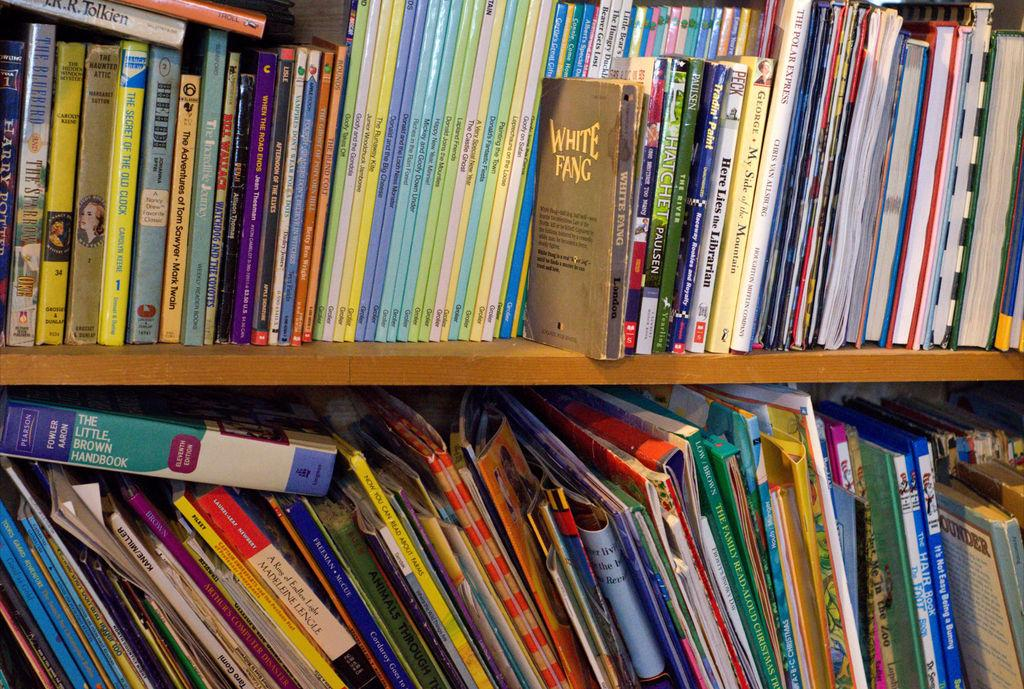<image>
Provide a brief description of the given image. A bookshelf that is full of books, one of which says White Fang 